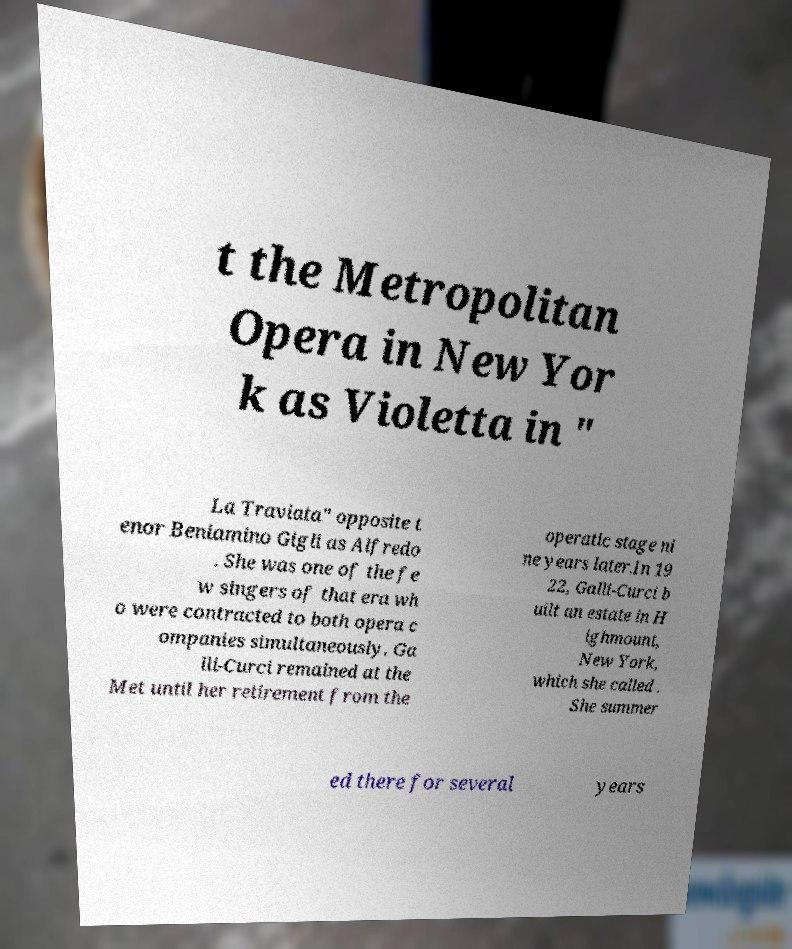Could you extract and type out the text from this image? t the Metropolitan Opera in New Yor k as Violetta in " La Traviata" opposite t enor Beniamino Gigli as Alfredo . She was one of the fe w singers of that era wh o were contracted to both opera c ompanies simultaneously. Ga lli-Curci remained at the Met until her retirement from the operatic stage ni ne years later.In 19 22, Galli-Curci b uilt an estate in H ighmount, New York, which she called . She summer ed there for several years 